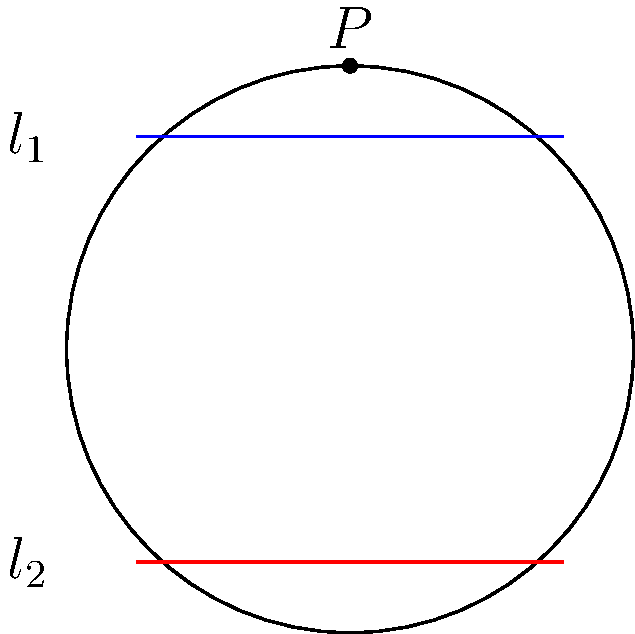In the hyperbolic plane model shown above (represented by the Poincaré disk), two lines $l_1$ (blue) and $l_2$ (red) are drawn. Given that these lines do not intersect within the disk, what can be concluded about their relationship in hyperbolic geometry? To understand the relationship between these lines in hyperbolic geometry, let's follow these steps:

1) In Euclidean geometry, parallel lines are equidistant and never intersect. However, hyperbolic geometry follows different rules.

2) In the Poincaré disk model of hyperbolic geometry:
   - The disk represents the entire hyperbolic plane.
   - Straight lines in hyperbolic geometry are represented by either:
     a) Diameters of the disk
     b) Circular arcs that intersect the boundary circle perpendicularly

3) Observing the given diagram:
   - Both $l_1$ and $l_2$ are represented by straight line segments.
   - These segments, if extended, would form circular arcs intersecting the boundary circle perpendicularly.
   - The lines do not intersect within the disk.

4) In hyperbolic geometry:
   - Lines that do not intersect are considered parallel.
   - However, unlike in Euclidean geometry, there can be multiple lines parallel to a given line through a point not on that line.

5) Therefore, in this hyperbolic plane:
   - Lines $l_1$ and $l_2$ are parallel to each other.
   - They will diverge from each other as they approach the edge of the disk.
   - This divergence is a key feature of hyperbolic geometry, known as "ultra-parallel" or "divergently parallel" lines.

Thus, while $l_1$ and $l_2$ are parallel, their behavior is fundamentally different from parallel lines in Euclidean geometry.
Answer: $l_1$ and $l_2$ are parallel but divergent (ultra-parallel) in hyperbolic geometry. 